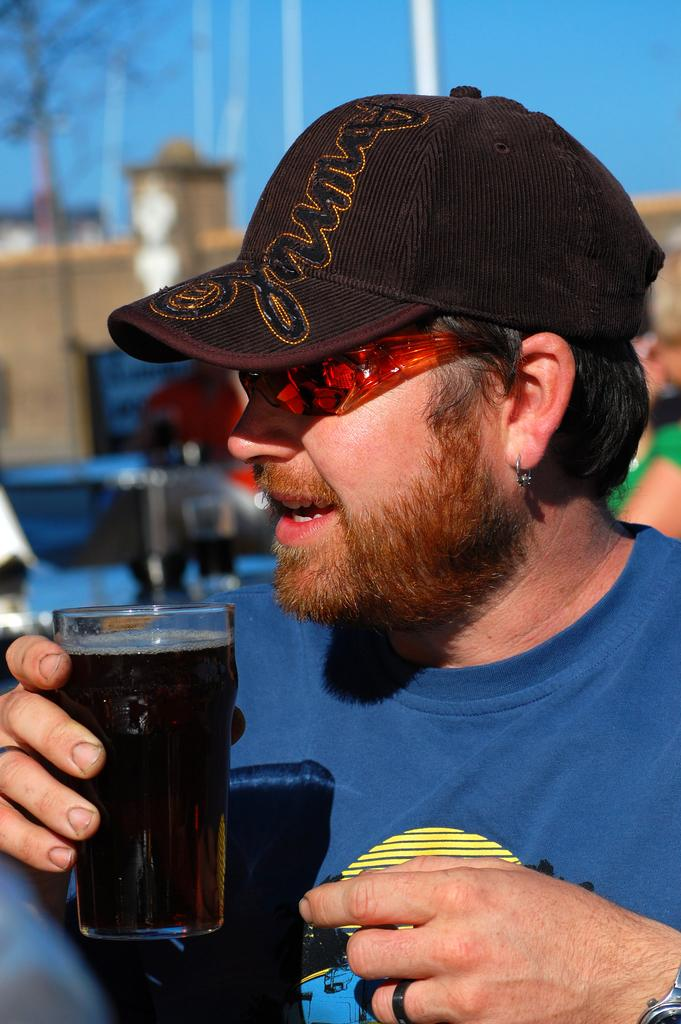What is the main subject of the image? There is a person in the image. What is the person holding in the image? The person is holding a glass of cool drink. What type of protective eyewear is the person wearing? The person is wearing goggles. What type of headwear is the person wearing? The person is wearing a cap. What type of kitty can be seen playing with the person in the image? There is no kitty present in the image; the person is the main subject. 